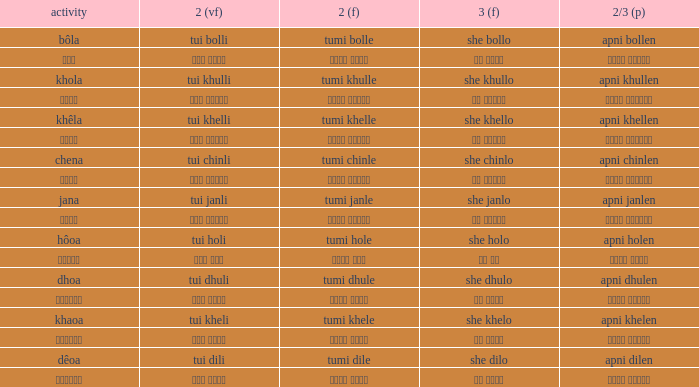What is the 2nd verb for Khola? Tumi khulle. 